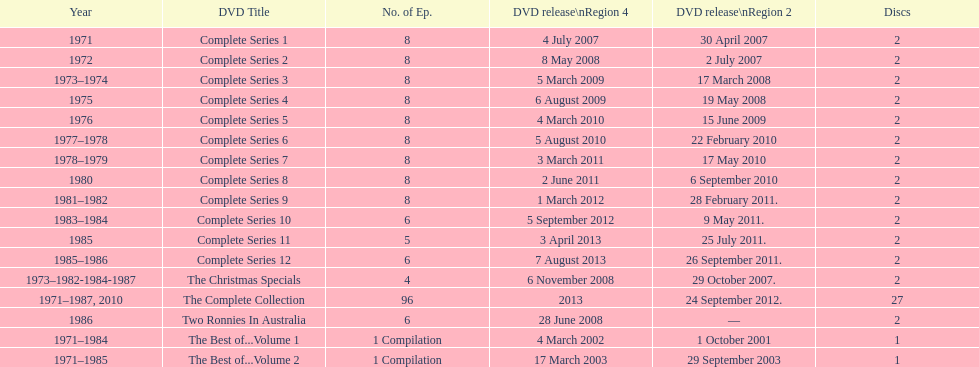What is the total of all dics listed in the table? 57. 